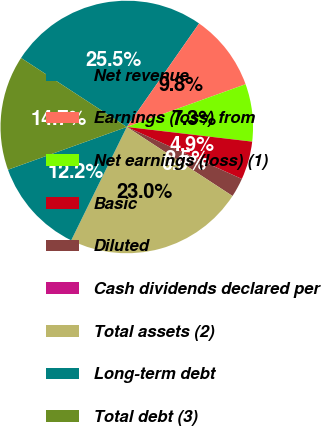<chart> <loc_0><loc_0><loc_500><loc_500><pie_chart><fcel>Net revenue<fcel>Earnings (loss) from<fcel>Net earnings (loss) (1)<fcel>Basic<fcel>Diluted<fcel>Cash dividends declared per<fcel>Total assets (2)<fcel>Long-term debt<fcel>Total debt (3)<nl><fcel>25.5%<fcel>9.8%<fcel>7.35%<fcel>4.9%<fcel>2.45%<fcel>0.0%<fcel>23.05%<fcel>12.25%<fcel>14.7%<nl></chart> 